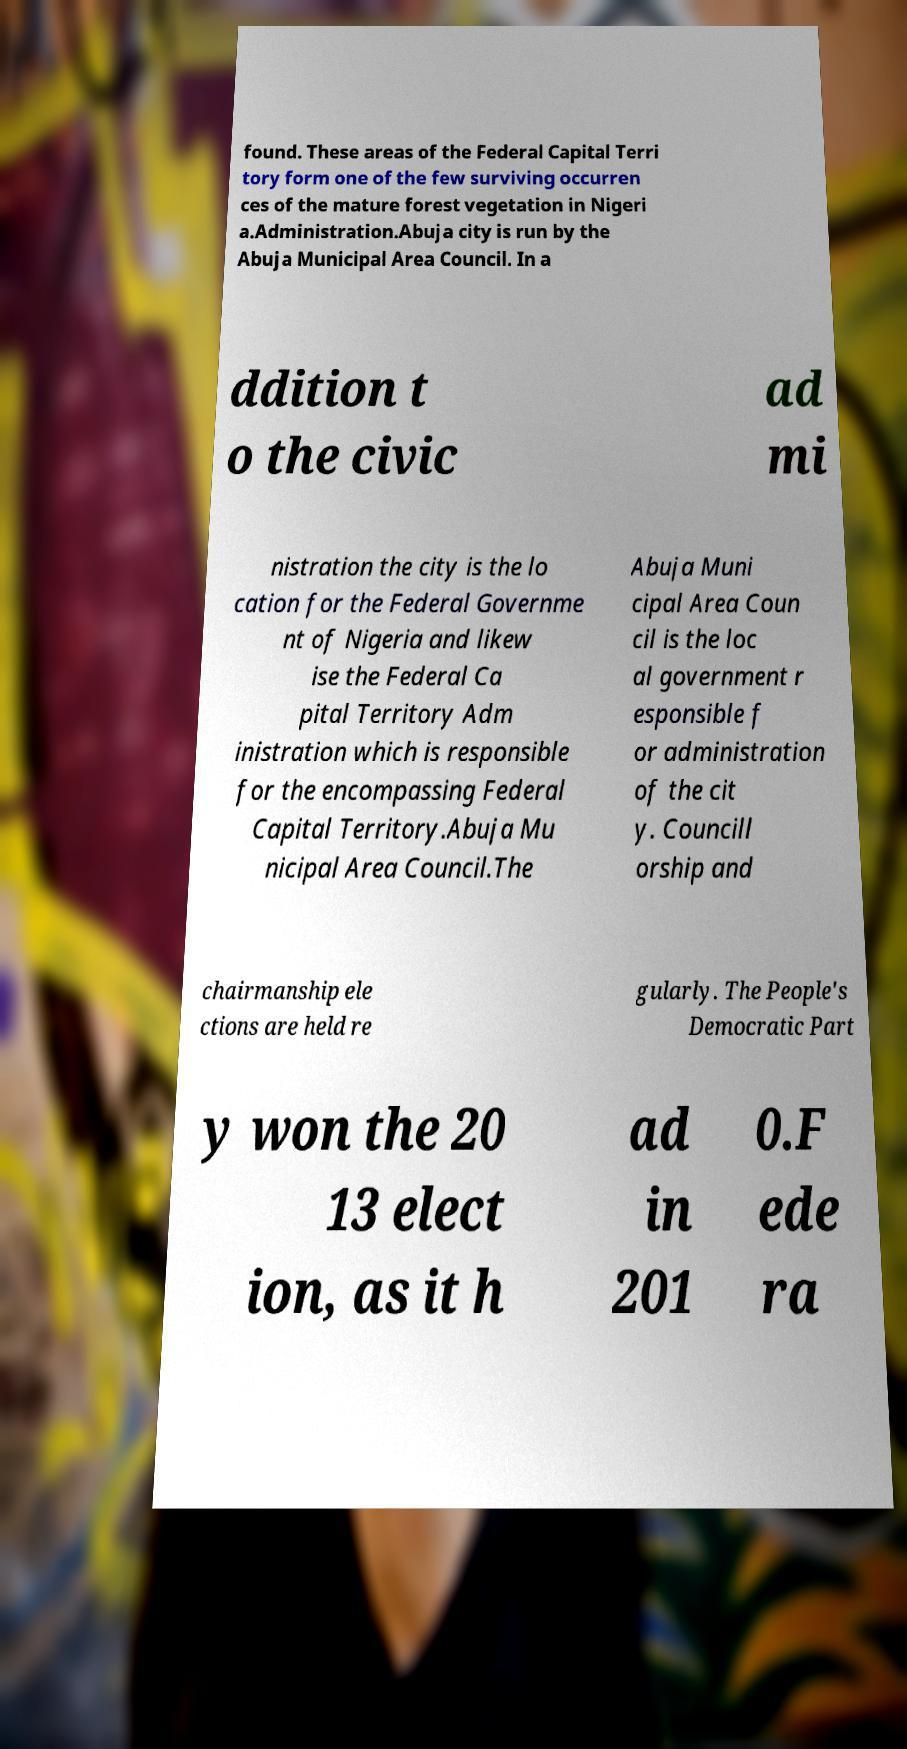Can you accurately transcribe the text from the provided image for me? found. These areas of the Federal Capital Terri tory form one of the few surviving occurren ces of the mature forest vegetation in Nigeri a.Administration.Abuja city is run by the Abuja Municipal Area Council. In a ddition t o the civic ad mi nistration the city is the lo cation for the Federal Governme nt of Nigeria and likew ise the Federal Ca pital Territory Adm inistration which is responsible for the encompassing Federal Capital Territory.Abuja Mu nicipal Area Council.The Abuja Muni cipal Area Coun cil is the loc al government r esponsible f or administration of the cit y. Councill orship and chairmanship ele ctions are held re gularly. The People's Democratic Part y won the 20 13 elect ion, as it h ad in 201 0.F ede ra 